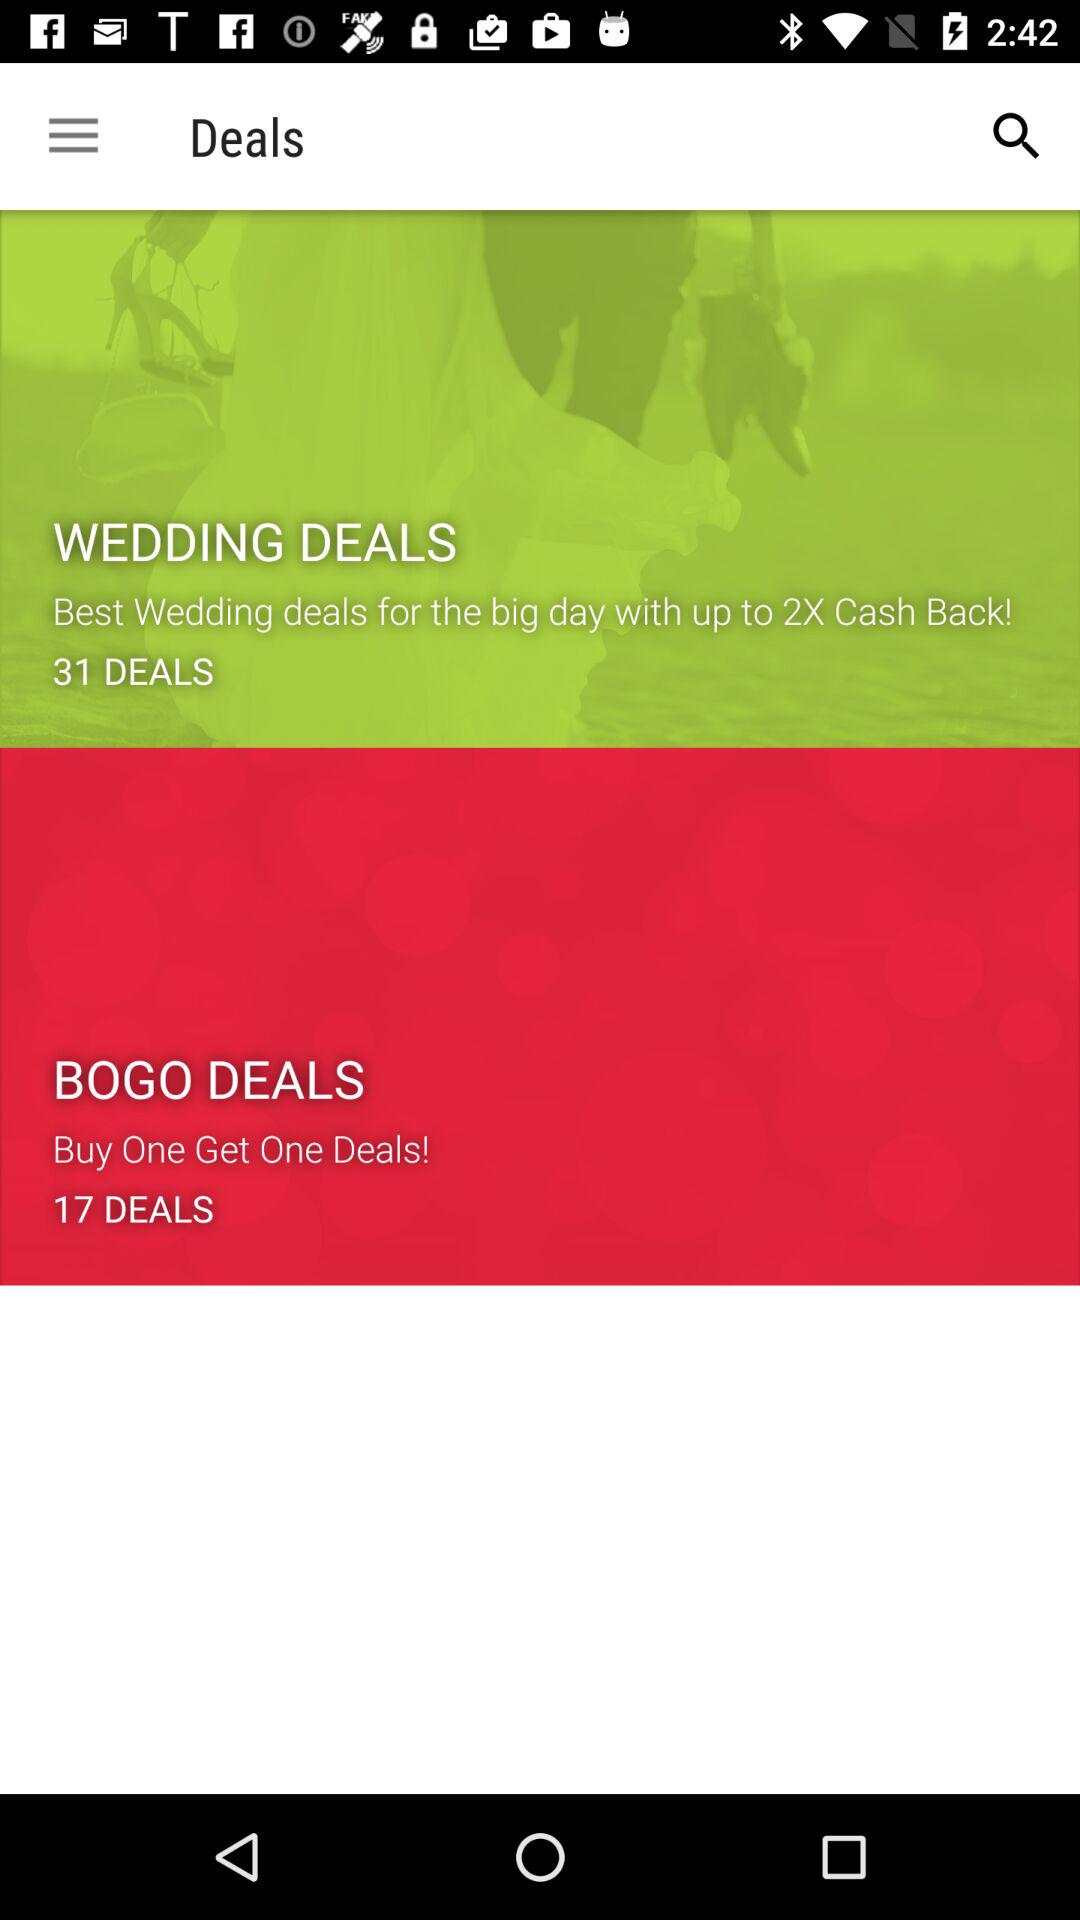What's on offer on Bogo Deals?
When the provided information is insufficient, respond with <no answer>. <no answer> 